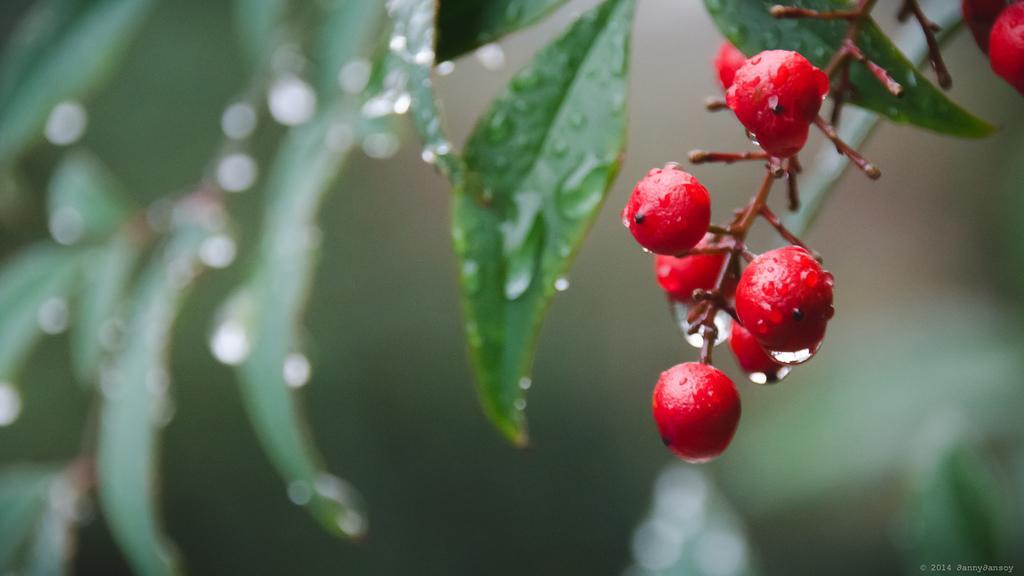How would you summarize this image in a sentence or two? In this image there are cherries in the middle. In the background there are green leaves on which there are droplets of water. 